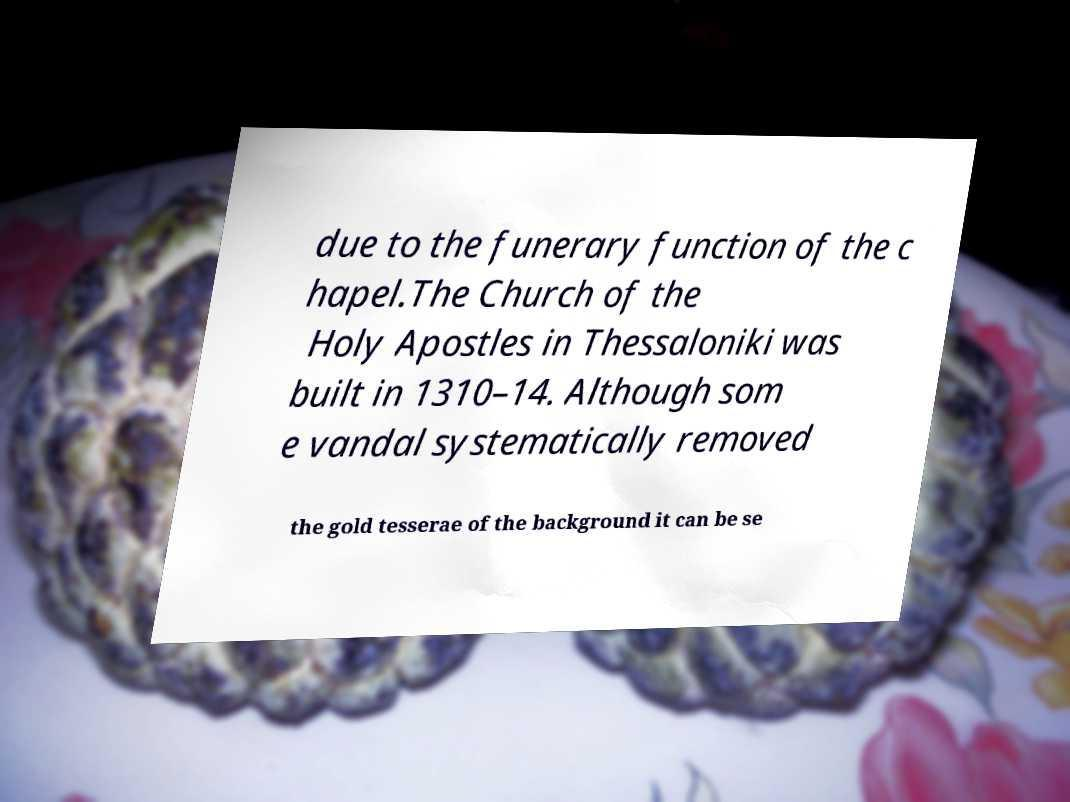I need the written content from this picture converted into text. Can you do that? due to the funerary function of the c hapel.The Church of the Holy Apostles in Thessaloniki was built in 1310–14. Although som e vandal systematically removed the gold tesserae of the background it can be se 